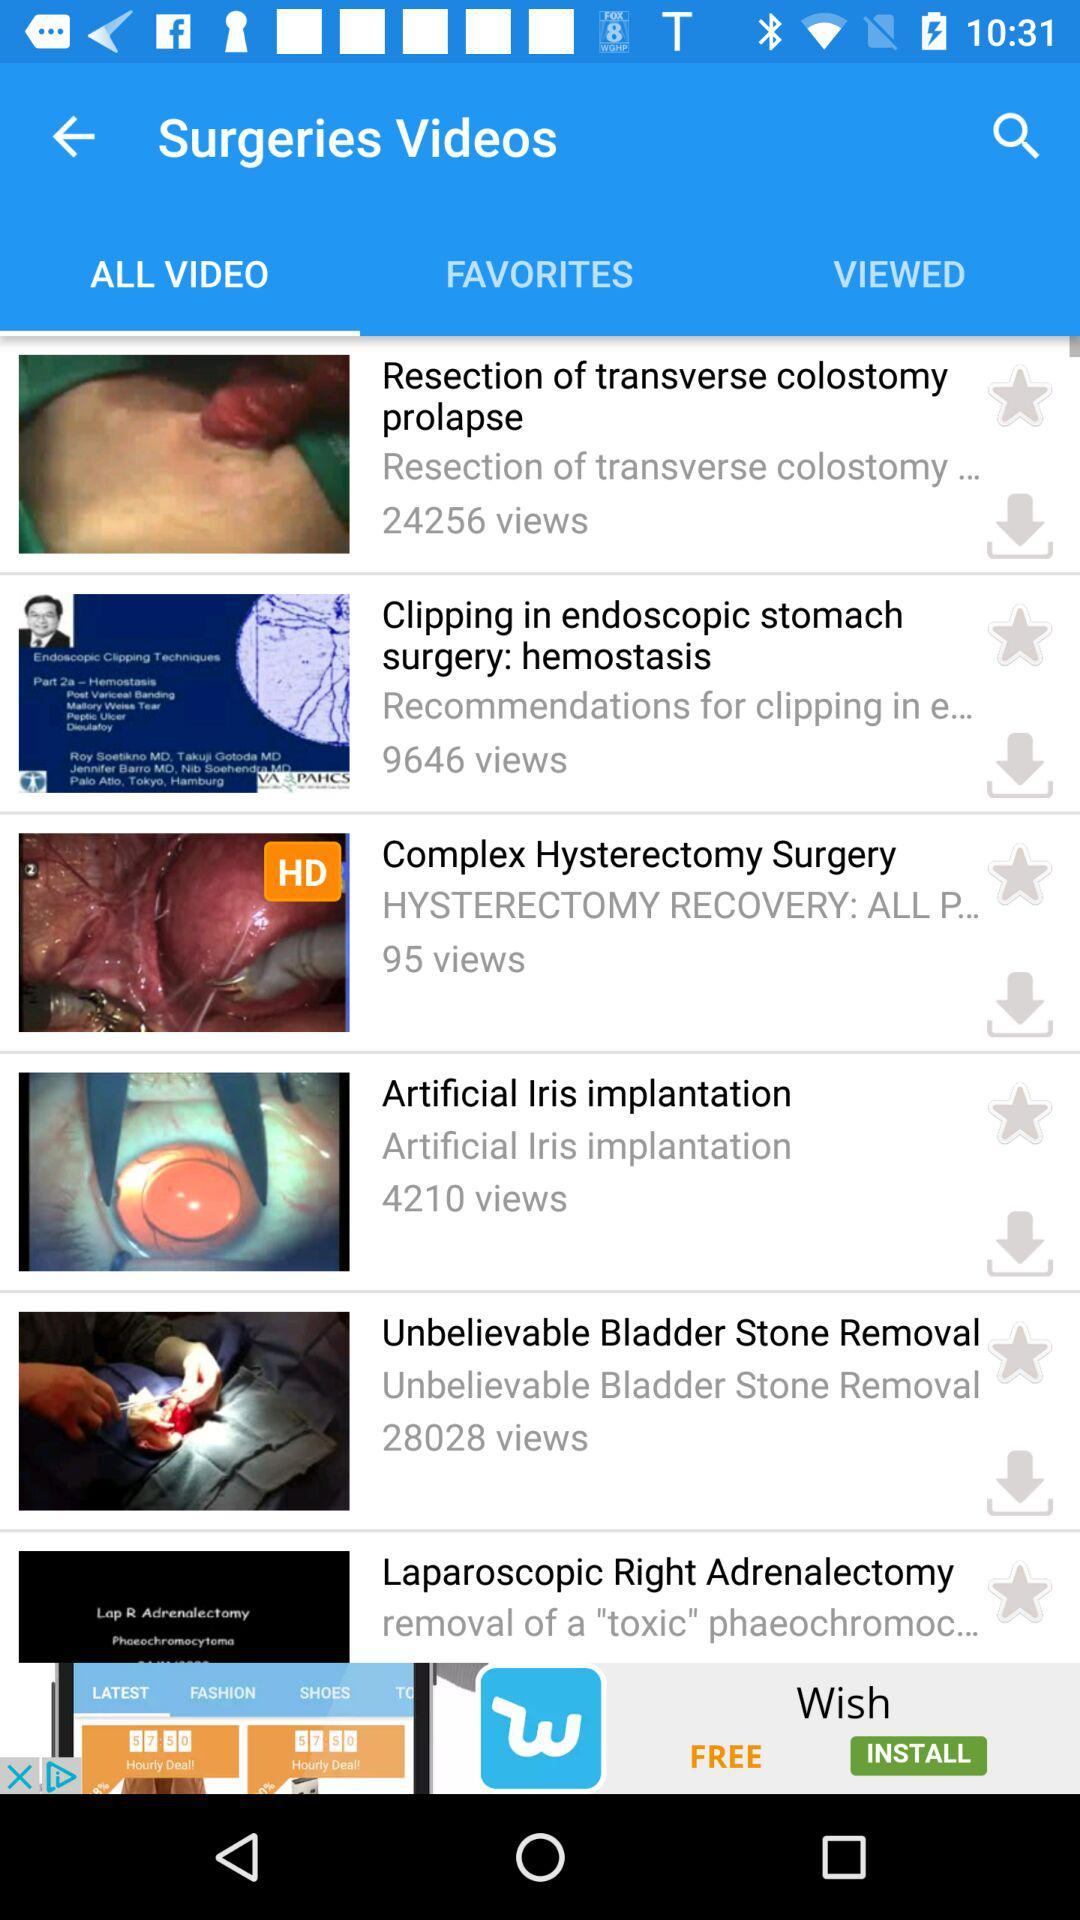How many views are there of "Artificial Iris Implantation"? There are 4210 views of "Artificial Iris Implantation". 